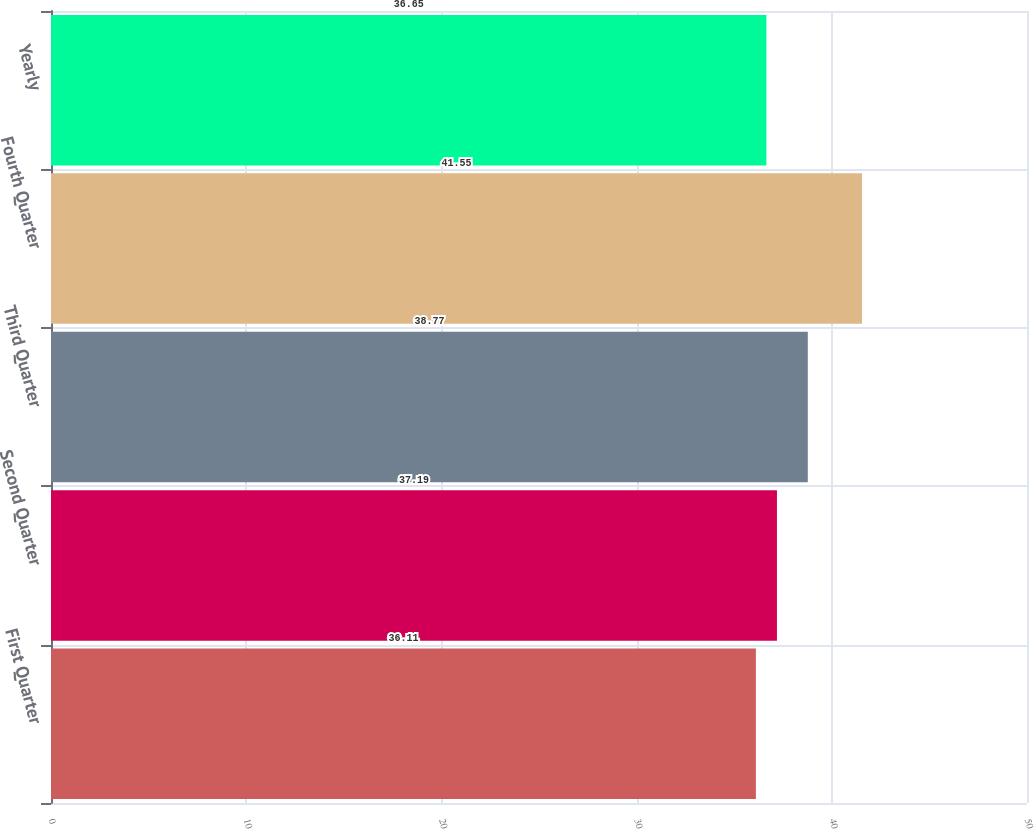Convert chart to OTSL. <chart><loc_0><loc_0><loc_500><loc_500><bar_chart><fcel>First Quarter<fcel>Second Quarter<fcel>Third Quarter<fcel>Fourth Quarter<fcel>Yearly<nl><fcel>36.11<fcel>37.19<fcel>38.77<fcel>41.55<fcel>36.65<nl></chart> 